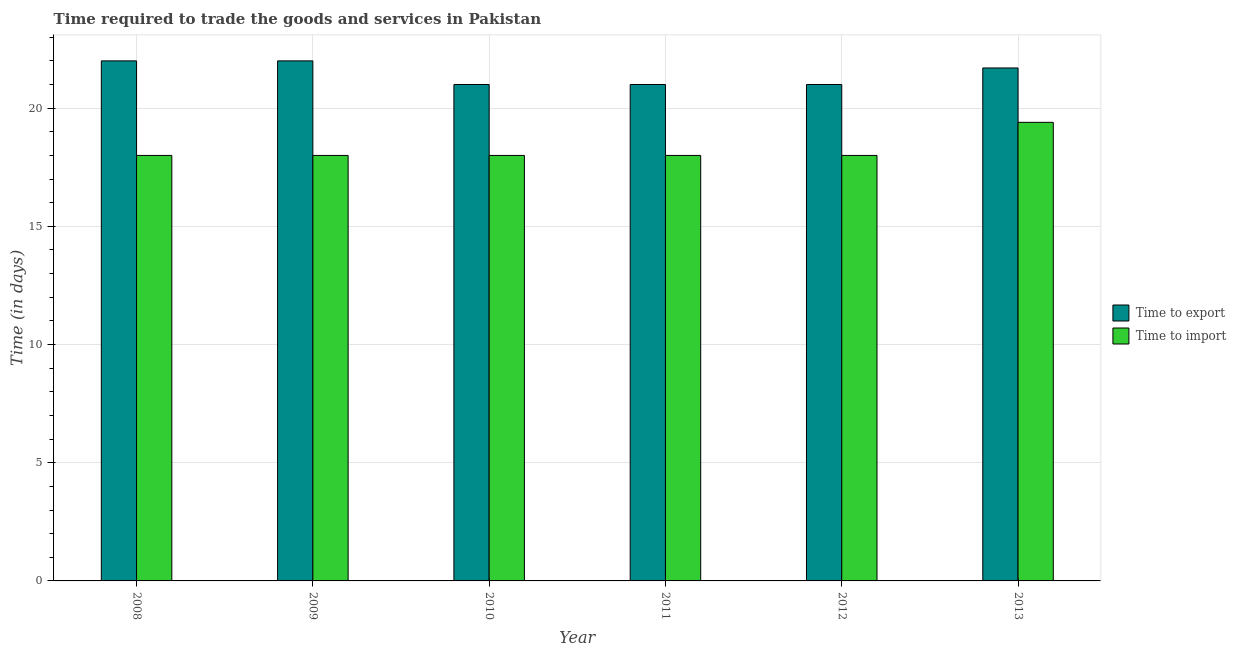How many different coloured bars are there?
Ensure brevity in your answer.  2. Are the number of bars per tick equal to the number of legend labels?
Give a very brief answer. Yes. How many bars are there on the 5th tick from the left?
Make the answer very short. 2. In how many cases, is the number of bars for a given year not equal to the number of legend labels?
Ensure brevity in your answer.  0. What is the time to export in 2012?
Your answer should be very brief. 21. Across all years, what is the maximum time to import?
Give a very brief answer. 19.4. In which year was the time to import minimum?
Provide a succinct answer. 2008. What is the total time to import in the graph?
Provide a short and direct response. 109.4. What is the difference between the time to import in 2013 and the time to export in 2011?
Ensure brevity in your answer.  1.4. What is the average time to export per year?
Your response must be concise. 21.45. In how many years, is the time to import greater than 22 days?
Offer a very short reply. 0. What is the difference between the highest and the second highest time to import?
Your response must be concise. 1.4. What does the 2nd bar from the left in 2009 represents?
Keep it short and to the point. Time to import. What does the 1st bar from the right in 2010 represents?
Give a very brief answer. Time to import. How many bars are there?
Give a very brief answer. 12. How many years are there in the graph?
Provide a short and direct response. 6. Are the values on the major ticks of Y-axis written in scientific E-notation?
Make the answer very short. No. Where does the legend appear in the graph?
Your response must be concise. Center right. What is the title of the graph?
Give a very brief answer. Time required to trade the goods and services in Pakistan. What is the label or title of the Y-axis?
Make the answer very short. Time (in days). What is the Time (in days) in Time to export in 2008?
Your answer should be very brief. 22. What is the Time (in days) of Time to export in 2009?
Give a very brief answer. 22. What is the Time (in days) in Time to import in 2010?
Your answer should be compact. 18. What is the Time (in days) in Time to export in 2011?
Give a very brief answer. 21. What is the Time (in days) in Time to import in 2011?
Keep it short and to the point. 18. What is the Time (in days) in Time to export in 2012?
Make the answer very short. 21. What is the Time (in days) of Time to export in 2013?
Your answer should be very brief. 21.7. Across all years, what is the maximum Time (in days) of Time to export?
Keep it short and to the point. 22. Across all years, what is the minimum Time (in days) of Time to export?
Give a very brief answer. 21. Across all years, what is the minimum Time (in days) in Time to import?
Ensure brevity in your answer.  18. What is the total Time (in days) of Time to export in the graph?
Your response must be concise. 128.7. What is the total Time (in days) in Time to import in the graph?
Your answer should be very brief. 109.4. What is the difference between the Time (in days) of Time to export in 2008 and that in 2009?
Provide a short and direct response. 0. What is the difference between the Time (in days) of Time to import in 2008 and that in 2009?
Ensure brevity in your answer.  0. What is the difference between the Time (in days) of Time to export in 2008 and that in 2010?
Keep it short and to the point. 1. What is the difference between the Time (in days) in Time to export in 2008 and that in 2012?
Your response must be concise. 1. What is the difference between the Time (in days) of Time to export in 2008 and that in 2013?
Your answer should be compact. 0.3. What is the difference between the Time (in days) in Time to import in 2008 and that in 2013?
Offer a terse response. -1.4. What is the difference between the Time (in days) of Time to export in 2009 and that in 2012?
Provide a short and direct response. 1. What is the difference between the Time (in days) of Time to import in 2009 and that in 2012?
Ensure brevity in your answer.  0. What is the difference between the Time (in days) in Time to import in 2010 and that in 2011?
Offer a terse response. 0. What is the difference between the Time (in days) of Time to export in 2010 and that in 2012?
Provide a succinct answer. 0. What is the difference between the Time (in days) of Time to import in 2010 and that in 2012?
Your answer should be very brief. 0. What is the difference between the Time (in days) in Time to import in 2010 and that in 2013?
Ensure brevity in your answer.  -1.4. What is the difference between the Time (in days) of Time to export in 2011 and that in 2012?
Provide a short and direct response. 0. What is the difference between the Time (in days) in Time to export in 2011 and that in 2013?
Provide a short and direct response. -0.7. What is the difference between the Time (in days) of Time to import in 2011 and that in 2013?
Ensure brevity in your answer.  -1.4. What is the difference between the Time (in days) in Time to export in 2012 and that in 2013?
Your answer should be very brief. -0.7. What is the difference between the Time (in days) of Time to import in 2012 and that in 2013?
Offer a terse response. -1.4. What is the difference between the Time (in days) in Time to export in 2008 and the Time (in days) in Time to import in 2012?
Ensure brevity in your answer.  4. What is the difference between the Time (in days) in Time to export in 2009 and the Time (in days) in Time to import in 2013?
Your answer should be very brief. 2.6. What is the difference between the Time (in days) of Time to export in 2010 and the Time (in days) of Time to import in 2011?
Your answer should be very brief. 3. What is the difference between the Time (in days) of Time to export in 2010 and the Time (in days) of Time to import in 2013?
Offer a very short reply. 1.6. What is the difference between the Time (in days) of Time to export in 2011 and the Time (in days) of Time to import in 2012?
Make the answer very short. 3. What is the average Time (in days) of Time to export per year?
Provide a succinct answer. 21.45. What is the average Time (in days) in Time to import per year?
Your response must be concise. 18.23. In the year 2009, what is the difference between the Time (in days) in Time to export and Time (in days) in Time to import?
Give a very brief answer. 4. In the year 2010, what is the difference between the Time (in days) in Time to export and Time (in days) in Time to import?
Provide a succinct answer. 3. In the year 2012, what is the difference between the Time (in days) of Time to export and Time (in days) of Time to import?
Give a very brief answer. 3. What is the ratio of the Time (in days) of Time to import in 2008 to that in 2009?
Make the answer very short. 1. What is the ratio of the Time (in days) of Time to export in 2008 to that in 2010?
Your answer should be very brief. 1.05. What is the ratio of the Time (in days) in Time to export in 2008 to that in 2011?
Offer a terse response. 1.05. What is the ratio of the Time (in days) of Time to import in 2008 to that in 2011?
Offer a very short reply. 1. What is the ratio of the Time (in days) in Time to export in 2008 to that in 2012?
Your response must be concise. 1.05. What is the ratio of the Time (in days) of Time to import in 2008 to that in 2012?
Your response must be concise. 1. What is the ratio of the Time (in days) of Time to export in 2008 to that in 2013?
Your response must be concise. 1.01. What is the ratio of the Time (in days) in Time to import in 2008 to that in 2013?
Keep it short and to the point. 0.93. What is the ratio of the Time (in days) in Time to export in 2009 to that in 2010?
Your answer should be compact. 1.05. What is the ratio of the Time (in days) in Time to import in 2009 to that in 2010?
Your answer should be very brief. 1. What is the ratio of the Time (in days) of Time to export in 2009 to that in 2011?
Provide a short and direct response. 1.05. What is the ratio of the Time (in days) in Time to import in 2009 to that in 2011?
Your answer should be very brief. 1. What is the ratio of the Time (in days) in Time to export in 2009 to that in 2012?
Give a very brief answer. 1.05. What is the ratio of the Time (in days) in Time to import in 2009 to that in 2012?
Offer a very short reply. 1. What is the ratio of the Time (in days) in Time to export in 2009 to that in 2013?
Your answer should be compact. 1.01. What is the ratio of the Time (in days) in Time to import in 2009 to that in 2013?
Give a very brief answer. 0.93. What is the ratio of the Time (in days) in Time to import in 2010 to that in 2011?
Ensure brevity in your answer.  1. What is the ratio of the Time (in days) of Time to import in 2010 to that in 2012?
Offer a very short reply. 1. What is the ratio of the Time (in days) of Time to export in 2010 to that in 2013?
Provide a short and direct response. 0.97. What is the ratio of the Time (in days) in Time to import in 2010 to that in 2013?
Give a very brief answer. 0.93. What is the ratio of the Time (in days) in Time to export in 2011 to that in 2012?
Give a very brief answer. 1. What is the ratio of the Time (in days) in Time to import in 2011 to that in 2012?
Provide a succinct answer. 1. What is the ratio of the Time (in days) of Time to export in 2011 to that in 2013?
Your answer should be compact. 0.97. What is the ratio of the Time (in days) of Time to import in 2011 to that in 2013?
Offer a very short reply. 0.93. What is the ratio of the Time (in days) in Time to export in 2012 to that in 2013?
Make the answer very short. 0.97. What is the ratio of the Time (in days) in Time to import in 2012 to that in 2013?
Ensure brevity in your answer.  0.93. What is the difference between the highest and the second highest Time (in days) of Time to export?
Provide a short and direct response. 0. What is the difference between the highest and the second highest Time (in days) in Time to import?
Offer a very short reply. 1.4. What is the difference between the highest and the lowest Time (in days) in Time to export?
Offer a very short reply. 1. 